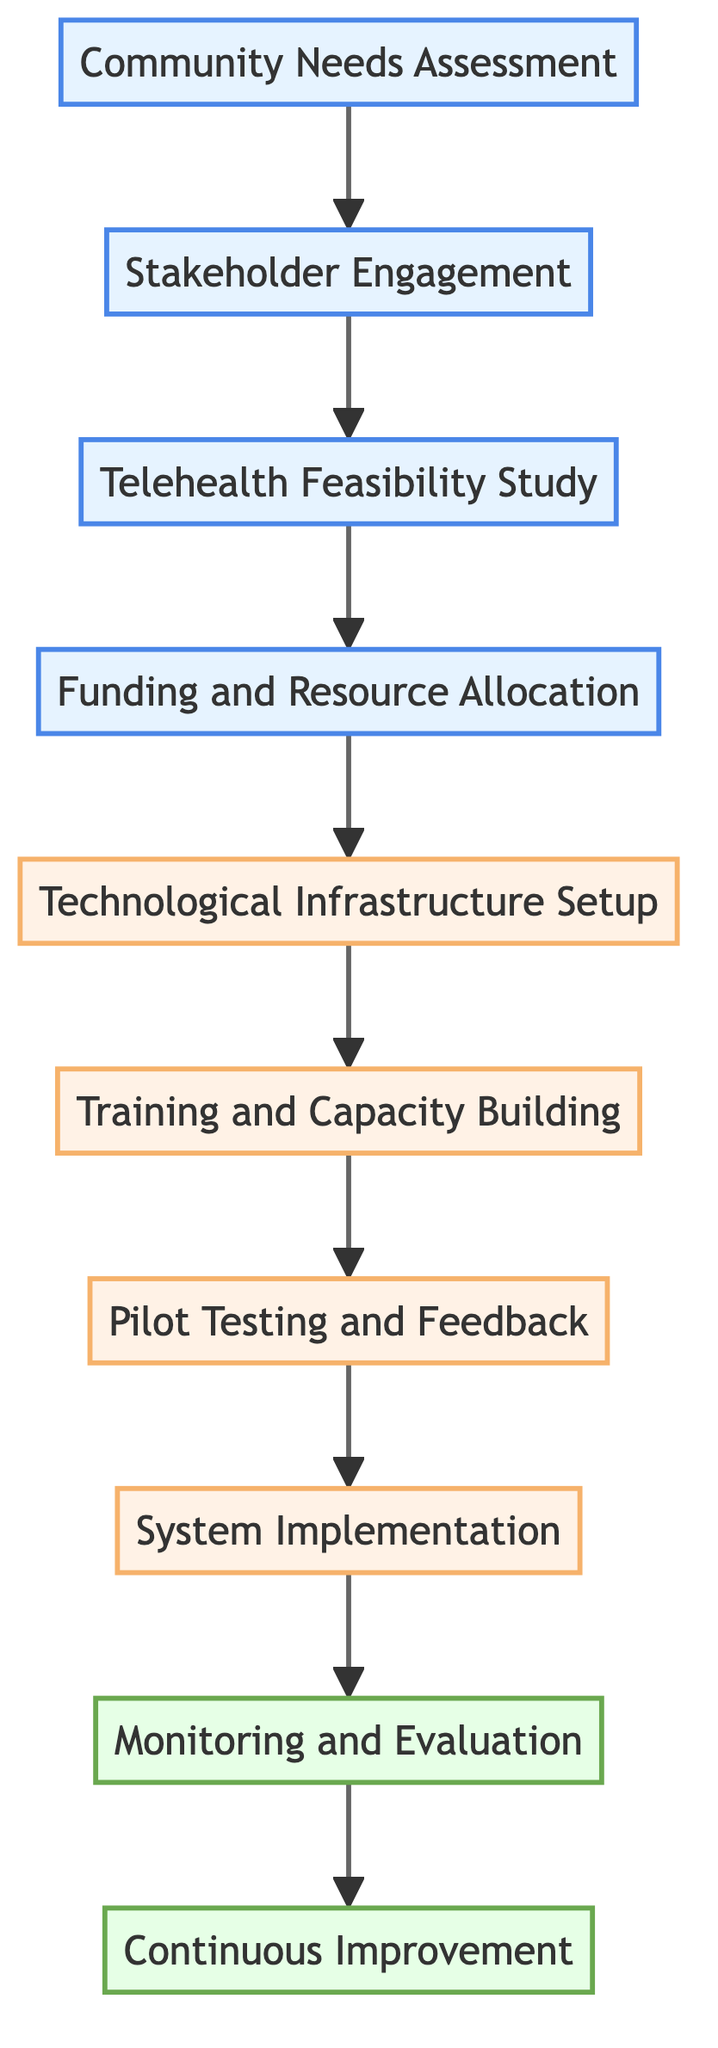What is the first step in the diagram? The diagram starts with the node labeled "Community Needs Assessment," indicating it is the first step in the process.
Answer: Community Needs Assessment How many nodes are present in the diagram? By counting all the unique labeled nodes, we find there are ten nodes in total.
Answer: 10 Which node follows "Telehealth Feasibility Study"? Following the directed connection from "Telehealth Feasibility Study," the next node is "Funding and Resource Allocation."
Answer: Funding and Resource Allocation What is the last step in the sequence? The final node in the flow is "Continuous Improvement," which signifies the last step in the process according to the diagram.
Answer: Continuous Improvement Which phase does "System Implementation" belong to? "System Implementation" is labeled in phase two, which involves the actual deployment of the telehealth services.
Answer: Phase two What is the relationship between "Training and Capacity Building" and "Pilot Testing and Feedback"? "Training and Capacity Building" directly leads into "Pilot Testing and Feedback," indicating that training must occur before feedback can be gathered from the pilot tests.
Answer: Directly connected What is the second step in the telehealth development process? The second step in the sequence is "Stakeholder Engagement," which follows "Community Needs Assessment."
Answer: Stakeholder Engagement Which nodes are part of phase three? The nodes that belong to phase three include "Monitoring and Evaluation" and "Continuous Improvement," both of which focus on assessing and refining the system after implementation.
Answer: Monitoring and Evaluation, Continuous Improvement What is the sequence of node labels from the start to the end of the process? Following the directed path from start to finish, the sequence of labels is: Community Needs Assessment, Stakeholder Engagement, Telehealth Feasibility Study, Funding and Resource Allocation, Technological Infrastructure Setup, Training and Capacity Building, Pilot Testing and Feedback, System Implementation, Monitoring and Evaluation, Continuous Improvement.
Answer: Community Needs Assessment, Stakeholder Engagement, Telehealth Feasibility Study, Funding and Resource Allocation, Technological Infrastructure Setup, Training and Capacity Building, Pilot Testing and Feedback, System Implementation, Monitoring and Evaluation, Continuous Improvement 